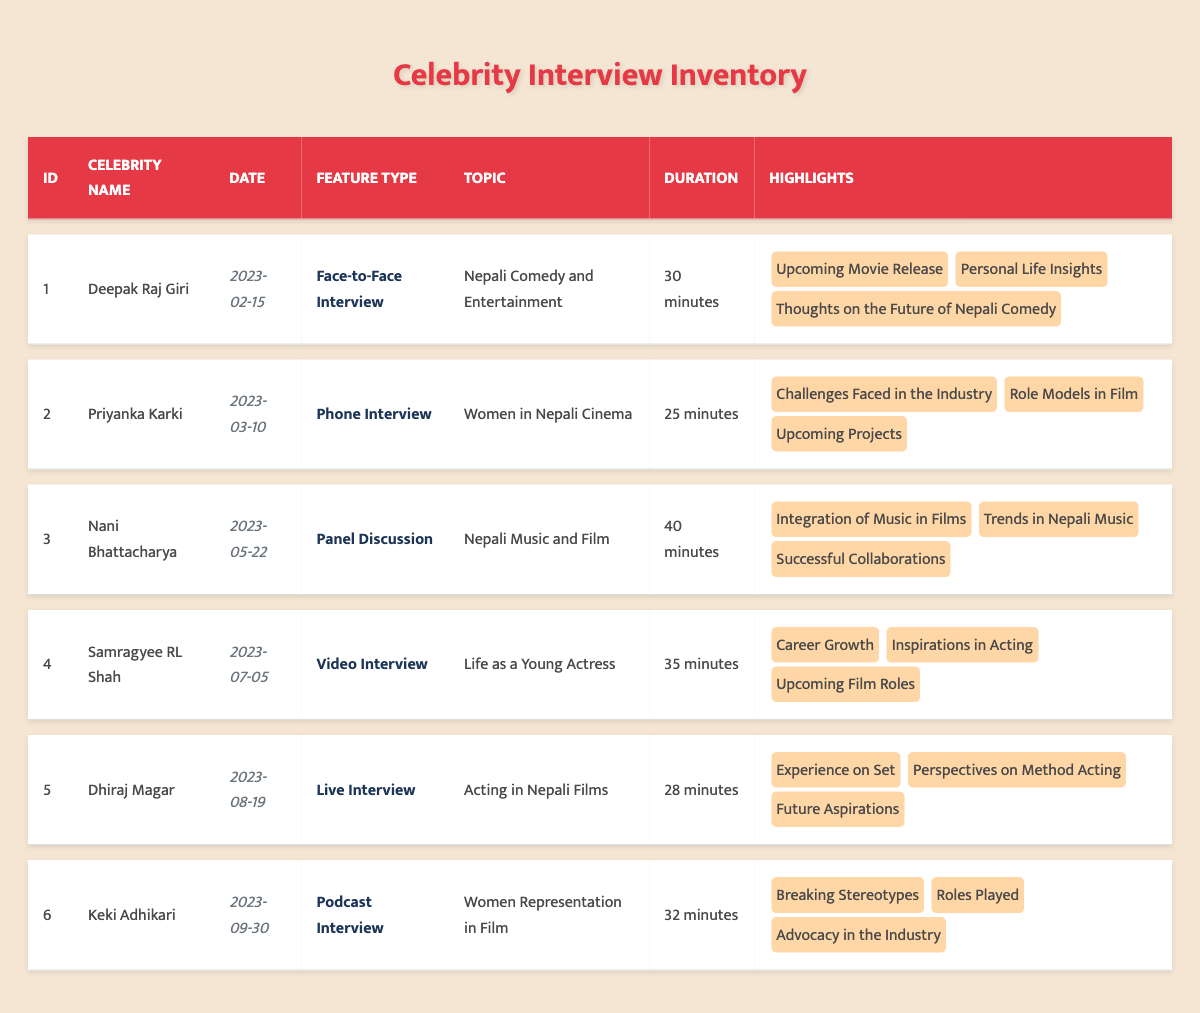What is the duration of the interview with Deepak Raj Giri? From the table, the "Duration" entry for Deepak Raj Giri's interview is directly listed as "30 minutes."
Answer: 30 minutes Which celebrity was interviewed on the date of "2023-03-10"? Looking at the table, on the date "2023-03-10," the celebrity interviewed was Priyanka Karki.
Answer: Priyanka Karki How many interviews were conducted in total? By counting the number of entries in the table, there are six individual interviews listed.
Answer: 6 What is the common duration of the interviews? To find the common duration, we review the durations: 30, 25, 40, 35, 28, and 32 minutes. Each is different; thus, there is no common duration among interviews.
Answer: No common duration Was there an interview focused on “Women in Nepali Cinema”? The table shows that the interview with Priyanka Karki was specifically focused on “Women in Nepali Cinema.” Therefore, the answer is yes.
Answer: Yes What is the average duration of the interviews? Adding the durations: 30 + 25 + 40 + 35 + 28 + 32 = 190 minutes. Since there are six interviews, the average duration is 190/6 = 31.67 minutes.
Answer: 31.67 minutes Which celebrity participated in the latest interview according to the table? The latest date in the table is "2023-09-30," which corresponds to the interview with Keki Adhikari.
Answer: Keki Adhikari How many phone interviews were conducted in total? By scanning the table, only the interview with Priyanka Karki is labeled as a "Phone Interview." So, there is one phone interview.
Answer: 1 Did Samragyee RL Shah discuss her upcoming film roles in her interview? The highlights for Samragyee RL Shah’s interview include "Upcoming Film Roles," confirming the topic was discussed. Therefore, the answer is yes.
Answer: Yes 